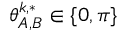<formula> <loc_0><loc_0><loc_500><loc_500>\theta _ { A , B } ^ { k , * } \in \{ 0 , \pi \}</formula> 